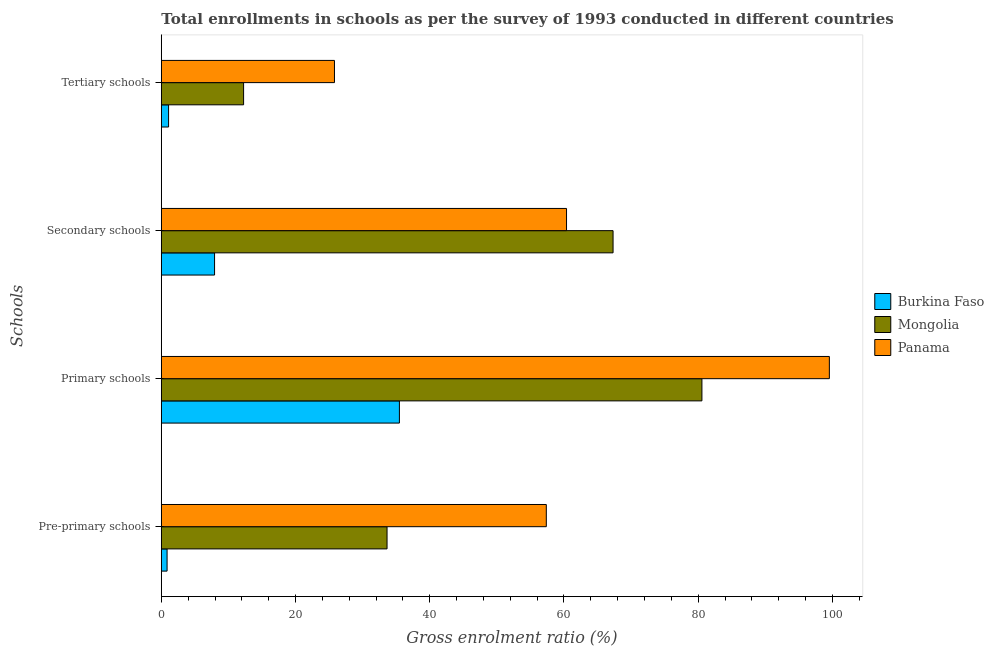Are the number of bars on each tick of the Y-axis equal?
Offer a terse response. Yes. How many bars are there on the 2nd tick from the top?
Offer a very short reply. 3. How many bars are there on the 4th tick from the bottom?
Provide a short and direct response. 3. What is the label of the 4th group of bars from the top?
Make the answer very short. Pre-primary schools. What is the gross enrolment ratio in pre-primary schools in Panama?
Offer a terse response. 57.37. Across all countries, what is the maximum gross enrolment ratio in pre-primary schools?
Provide a succinct answer. 57.37. Across all countries, what is the minimum gross enrolment ratio in secondary schools?
Offer a terse response. 7.93. In which country was the gross enrolment ratio in pre-primary schools maximum?
Your answer should be very brief. Panama. In which country was the gross enrolment ratio in secondary schools minimum?
Provide a short and direct response. Burkina Faso. What is the total gross enrolment ratio in primary schools in the graph?
Your answer should be very brief. 215.58. What is the difference between the gross enrolment ratio in secondary schools in Mongolia and that in Burkina Faso?
Provide a short and direct response. 59.38. What is the difference between the gross enrolment ratio in secondary schools in Burkina Faso and the gross enrolment ratio in tertiary schools in Panama?
Offer a very short reply. -17.87. What is the average gross enrolment ratio in secondary schools per country?
Your response must be concise. 45.21. What is the difference between the gross enrolment ratio in primary schools and gross enrolment ratio in pre-primary schools in Mongolia?
Offer a terse response. 46.92. In how many countries, is the gross enrolment ratio in tertiary schools greater than 72 %?
Offer a terse response. 0. What is the ratio of the gross enrolment ratio in pre-primary schools in Panama to that in Burkina Faso?
Keep it short and to the point. 66.82. Is the gross enrolment ratio in secondary schools in Mongolia less than that in Burkina Faso?
Give a very brief answer. No. What is the difference between the highest and the second highest gross enrolment ratio in primary schools?
Offer a very short reply. 18.99. What is the difference between the highest and the lowest gross enrolment ratio in primary schools?
Your response must be concise. 64.07. Is the sum of the gross enrolment ratio in pre-primary schools in Burkina Faso and Mongolia greater than the maximum gross enrolment ratio in secondary schools across all countries?
Ensure brevity in your answer.  No. Is it the case that in every country, the sum of the gross enrolment ratio in pre-primary schools and gross enrolment ratio in tertiary schools is greater than the sum of gross enrolment ratio in secondary schools and gross enrolment ratio in primary schools?
Offer a very short reply. No. What does the 3rd bar from the top in Tertiary schools represents?
Your response must be concise. Burkina Faso. What does the 1st bar from the bottom in Secondary schools represents?
Your answer should be compact. Burkina Faso. Is it the case that in every country, the sum of the gross enrolment ratio in pre-primary schools and gross enrolment ratio in primary schools is greater than the gross enrolment ratio in secondary schools?
Your answer should be compact. Yes. What is the difference between two consecutive major ticks on the X-axis?
Your answer should be compact. 20. Are the values on the major ticks of X-axis written in scientific E-notation?
Provide a short and direct response. No. Does the graph contain grids?
Make the answer very short. No. How are the legend labels stacked?
Your answer should be very brief. Vertical. What is the title of the graph?
Give a very brief answer. Total enrollments in schools as per the survey of 1993 conducted in different countries. What is the label or title of the Y-axis?
Keep it short and to the point. Schools. What is the Gross enrolment ratio (%) in Burkina Faso in Pre-primary schools?
Offer a terse response. 0.86. What is the Gross enrolment ratio (%) in Mongolia in Pre-primary schools?
Offer a terse response. 33.64. What is the Gross enrolment ratio (%) in Panama in Pre-primary schools?
Keep it short and to the point. 57.37. What is the Gross enrolment ratio (%) in Burkina Faso in Primary schools?
Keep it short and to the point. 35.48. What is the Gross enrolment ratio (%) of Mongolia in Primary schools?
Keep it short and to the point. 80.56. What is the Gross enrolment ratio (%) of Panama in Primary schools?
Give a very brief answer. 99.54. What is the Gross enrolment ratio (%) in Burkina Faso in Secondary schools?
Offer a terse response. 7.93. What is the Gross enrolment ratio (%) in Mongolia in Secondary schools?
Give a very brief answer. 67.32. What is the Gross enrolment ratio (%) in Panama in Secondary schools?
Offer a very short reply. 60.38. What is the Gross enrolment ratio (%) of Burkina Faso in Tertiary schools?
Keep it short and to the point. 1.08. What is the Gross enrolment ratio (%) of Mongolia in Tertiary schools?
Provide a short and direct response. 12.26. What is the Gross enrolment ratio (%) of Panama in Tertiary schools?
Offer a very short reply. 25.8. Across all Schools, what is the maximum Gross enrolment ratio (%) in Burkina Faso?
Your answer should be compact. 35.48. Across all Schools, what is the maximum Gross enrolment ratio (%) in Mongolia?
Give a very brief answer. 80.56. Across all Schools, what is the maximum Gross enrolment ratio (%) of Panama?
Ensure brevity in your answer.  99.54. Across all Schools, what is the minimum Gross enrolment ratio (%) in Burkina Faso?
Ensure brevity in your answer.  0.86. Across all Schools, what is the minimum Gross enrolment ratio (%) in Mongolia?
Offer a terse response. 12.26. Across all Schools, what is the minimum Gross enrolment ratio (%) in Panama?
Your answer should be compact. 25.8. What is the total Gross enrolment ratio (%) in Burkina Faso in the graph?
Your response must be concise. 45.35. What is the total Gross enrolment ratio (%) in Mongolia in the graph?
Offer a very short reply. 193.77. What is the total Gross enrolment ratio (%) of Panama in the graph?
Provide a succinct answer. 243.09. What is the difference between the Gross enrolment ratio (%) in Burkina Faso in Pre-primary schools and that in Primary schools?
Your response must be concise. -34.62. What is the difference between the Gross enrolment ratio (%) of Mongolia in Pre-primary schools and that in Primary schools?
Offer a very short reply. -46.92. What is the difference between the Gross enrolment ratio (%) in Panama in Pre-primary schools and that in Primary schools?
Ensure brevity in your answer.  -42.18. What is the difference between the Gross enrolment ratio (%) of Burkina Faso in Pre-primary schools and that in Secondary schools?
Keep it short and to the point. -7.08. What is the difference between the Gross enrolment ratio (%) of Mongolia in Pre-primary schools and that in Secondary schools?
Your answer should be very brief. -33.68. What is the difference between the Gross enrolment ratio (%) in Panama in Pre-primary schools and that in Secondary schools?
Keep it short and to the point. -3.01. What is the difference between the Gross enrolment ratio (%) of Burkina Faso in Pre-primary schools and that in Tertiary schools?
Your answer should be compact. -0.22. What is the difference between the Gross enrolment ratio (%) in Mongolia in Pre-primary schools and that in Tertiary schools?
Provide a succinct answer. 21.38. What is the difference between the Gross enrolment ratio (%) of Panama in Pre-primary schools and that in Tertiary schools?
Offer a very short reply. 31.57. What is the difference between the Gross enrolment ratio (%) in Burkina Faso in Primary schools and that in Secondary schools?
Your response must be concise. 27.54. What is the difference between the Gross enrolment ratio (%) in Mongolia in Primary schools and that in Secondary schools?
Give a very brief answer. 13.24. What is the difference between the Gross enrolment ratio (%) of Panama in Primary schools and that in Secondary schools?
Keep it short and to the point. 39.16. What is the difference between the Gross enrolment ratio (%) of Burkina Faso in Primary schools and that in Tertiary schools?
Give a very brief answer. 34.39. What is the difference between the Gross enrolment ratio (%) of Mongolia in Primary schools and that in Tertiary schools?
Your response must be concise. 68.3. What is the difference between the Gross enrolment ratio (%) of Panama in Primary schools and that in Tertiary schools?
Provide a succinct answer. 73.74. What is the difference between the Gross enrolment ratio (%) of Burkina Faso in Secondary schools and that in Tertiary schools?
Offer a terse response. 6.85. What is the difference between the Gross enrolment ratio (%) of Mongolia in Secondary schools and that in Tertiary schools?
Keep it short and to the point. 55.05. What is the difference between the Gross enrolment ratio (%) in Panama in Secondary schools and that in Tertiary schools?
Ensure brevity in your answer.  34.58. What is the difference between the Gross enrolment ratio (%) in Burkina Faso in Pre-primary schools and the Gross enrolment ratio (%) in Mongolia in Primary schools?
Offer a terse response. -79.7. What is the difference between the Gross enrolment ratio (%) of Burkina Faso in Pre-primary schools and the Gross enrolment ratio (%) of Panama in Primary schools?
Your response must be concise. -98.69. What is the difference between the Gross enrolment ratio (%) of Mongolia in Pre-primary schools and the Gross enrolment ratio (%) of Panama in Primary schools?
Keep it short and to the point. -65.91. What is the difference between the Gross enrolment ratio (%) in Burkina Faso in Pre-primary schools and the Gross enrolment ratio (%) in Mongolia in Secondary schools?
Provide a short and direct response. -66.46. What is the difference between the Gross enrolment ratio (%) in Burkina Faso in Pre-primary schools and the Gross enrolment ratio (%) in Panama in Secondary schools?
Offer a very short reply. -59.52. What is the difference between the Gross enrolment ratio (%) of Mongolia in Pre-primary schools and the Gross enrolment ratio (%) of Panama in Secondary schools?
Ensure brevity in your answer.  -26.74. What is the difference between the Gross enrolment ratio (%) in Burkina Faso in Pre-primary schools and the Gross enrolment ratio (%) in Mongolia in Tertiary schools?
Your answer should be very brief. -11.4. What is the difference between the Gross enrolment ratio (%) in Burkina Faso in Pre-primary schools and the Gross enrolment ratio (%) in Panama in Tertiary schools?
Ensure brevity in your answer.  -24.94. What is the difference between the Gross enrolment ratio (%) of Mongolia in Pre-primary schools and the Gross enrolment ratio (%) of Panama in Tertiary schools?
Provide a succinct answer. 7.84. What is the difference between the Gross enrolment ratio (%) in Burkina Faso in Primary schools and the Gross enrolment ratio (%) in Mongolia in Secondary schools?
Ensure brevity in your answer.  -31.84. What is the difference between the Gross enrolment ratio (%) of Burkina Faso in Primary schools and the Gross enrolment ratio (%) of Panama in Secondary schools?
Your answer should be very brief. -24.9. What is the difference between the Gross enrolment ratio (%) in Mongolia in Primary schools and the Gross enrolment ratio (%) in Panama in Secondary schools?
Your answer should be very brief. 20.18. What is the difference between the Gross enrolment ratio (%) of Burkina Faso in Primary schools and the Gross enrolment ratio (%) of Mongolia in Tertiary schools?
Offer a terse response. 23.22. What is the difference between the Gross enrolment ratio (%) in Burkina Faso in Primary schools and the Gross enrolment ratio (%) in Panama in Tertiary schools?
Provide a short and direct response. 9.68. What is the difference between the Gross enrolment ratio (%) in Mongolia in Primary schools and the Gross enrolment ratio (%) in Panama in Tertiary schools?
Your response must be concise. 54.76. What is the difference between the Gross enrolment ratio (%) in Burkina Faso in Secondary schools and the Gross enrolment ratio (%) in Mongolia in Tertiary schools?
Ensure brevity in your answer.  -4.33. What is the difference between the Gross enrolment ratio (%) of Burkina Faso in Secondary schools and the Gross enrolment ratio (%) of Panama in Tertiary schools?
Your answer should be very brief. -17.87. What is the difference between the Gross enrolment ratio (%) in Mongolia in Secondary schools and the Gross enrolment ratio (%) in Panama in Tertiary schools?
Provide a succinct answer. 41.51. What is the average Gross enrolment ratio (%) in Burkina Faso per Schools?
Provide a short and direct response. 11.34. What is the average Gross enrolment ratio (%) of Mongolia per Schools?
Keep it short and to the point. 48.44. What is the average Gross enrolment ratio (%) in Panama per Schools?
Provide a succinct answer. 60.77. What is the difference between the Gross enrolment ratio (%) in Burkina Faso and Gross enrolment ratio (%) in Mongolia in Pre-primary schools?
Your answer should be compact. -32.78. What is the difference between the Gross enrolment ratio (%) of Burkina Faso and Gross enrolment ratio (%) of Panama in Pre-primary schools?
Ensure brevity in your answer.  -56.51. What is the difference between the Gross enrolment ratio (%) in Mongolia and Gross enrolment ratio (%) in Panama in Pre-primary schools?
Provide a short and direct response. -23.73. What is the difference between the Gross enrolment ratio (%) in Burkina Faso and Gross enrolment ratio (%) in Mongolia in Primary schools?
Provide a short and direct response. -45.08. What is the difference between the Gross enrolment ratio (%) in Burkina Faso and Gross enrolment ratio (%) in Panama in Primary schools?
Give a very brief answer. -64.07. What is the difference between the Gross enrolment ratio (%) in Mongolia and Gross enrolment ratio (%) in Panama in Primary schools?
Offer a very short reply. -18.99. What is the difference between the Gross enrolment ratio (%) in Burkina Faso and Gross enrolment ratio (%) in Mongolia in Secondary schools?
Your answer should be very brief. -59.38. What is the difference between the Gross enrolment ratio (%) of Burkina Faso and Gross enrolment ratio (%) of Panama in Secondary schools?
Ensure brevity in your answer.  -52.45. What is the difference between the Gross enrolment ratio (%) of Mongolia and Gross enrolment ratio (%) of Panama in Secondary schools?
Give a very brief answer. 6.93. What is the difference between the Gross enrolment ratio (%) of Burkina Faso and Gross enrolment ratio (%) of Mongolia in Tertiary schools?
Provide a short and direct response. -11.18. What is the difference between the Gross enrolment ratio (%) in Burkina Faso and Gross enrolment ratio (%) in Panama in Tertiary schools?
Make the answer very short. -24.72. What is the difference between the Gross enrolment ratio (%) in Mongolia and Gross enrolment ratio (%) in Panama in Tertiary schools?
Provide a succinct answer. -13.54. What is the ratio of the Gross enrolment ratio (%) of Burkina Faso in Pre-primary schools to that in Primary schools?
Your answer should be very brief. 0.02. What is the ratio of the Gross enrolment ratio (%) of Mongolia in Pre-primary schools to that in Primary schools?
Your response must be concise. 0.42. What is the ratio of the Gross enrolment ratio (%) of Panama in Pre-primary schools to that in Primary schools?
Your response must be concise. 0.58. What is the ratio of the Gross enrolment ratio (%) in Burkina Faso in Pre-primary schools to that in Secondary schools?
Give a very brief answer. 0.11. What is the ratio of the Gross enrolment ratio (%) of Mongolia in Pre-primary schools to that in Secondary schools?
Give a very brief answer. 0.5. What is the ratio of the Gross enrolment ratio (%) of Panama in Pre-primary schools to that in Secondary schools?
Your response must be concise. 0.95. What is the ratio of the Gross enrolment ratio (%) in Burkina Faso in Pre-primary schools to that in Tertiary schools?
Keep it short and to the point. 0.79. What is the ratio of the Gross enrolment ratio (%) in Mongolia in Pre-primary schools to that in Tertiary schools?
Keep it short and to the point. 2.74. What is the ratio of the Gross enrolment ratio (%) in Panama in Pre-primary schools to that in Tertiary schools?
Ensure brevity in your answer.  2.22. What is the ratio of the Gross enrolment ratio (%) in Burkina Faso in Primary schools to that in Secondary schools?
Offer a terse response. 4.47. What is the ratio of the Gross enrolment ratio (%) in Mongolia in Primary schools to that in Secondary schools?
Give a very brief answer. 1.2. What is the ratio of the Gross enrolment ratio (%) in Panama in Primary schools to that in Secondary schools?
Offer a very short reply. 1.65. What is the ratio of the Gross enrolment ratio (%) of Burkina Faso in Primary schools to that in Tertiary schools?
Your response must be concise. 32.79. What is the ratio of the Gross enrolment ratio (%) in Mongolia in Primary schools to that in Tertiary schools?
Your response must be concise. 6.57. What is the ratio of the Gross enrolment ratio (%) in Panama in Primary schools to that in Tertiary schools?
Offer a very short reply. 3.86. What is the ratio of the Gross enrolment ratio (%) of Burkina Faso in Secondary schools to that in Tertiary schools?
Provide a succinct answer. 7.33. What is the ratio of the Gross enrolment ratio (%) in Mongolia in Secondary schools to that in Tertiary schools?
Provide a short and direct response. 5.49. What is the ratio of the Gross enrolment ratio (%) in Panama in Secondary schools to that in Tertiary schools?
Your answer should be very brief. 2.34. What is the difference between the highest and the second highest Gross enrolment ratio (%) in Burkina Faso?
Make the answer very short. 27.54. What is the difference between the highest and the second highest Gross enrolment ratio (%) in Mongolia?
Your response must be concise. 13.24. What is the difference between the highest and the second highest Gross enrolment ratio (%) in Panama?
Provide a short and direct response. 39.16. What is the difference between the highest and the lowest Gross enrolment ratio (%) in Burkina Faso?
Offer a very short reply. 34.62. What is the difference between the highest and the lowest Gross enrolment ratio (%) of Mongolia?
Give a very brief answer. 68.3. What is the difference between the highest and the lowest Gross enrolment ratio (%) of Panama?
Offer a very short reply. 73.74. 